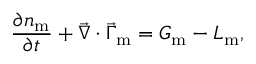<formula> <loc_0><loc_0><loc_500><loc_500>\frac { \partial { n _ { m } } } { \partial { t } } + \vec { \nabla } \cdot \vec { \Gamma } _ { m } = G _ { m } - L _ { m } ,</formula> 